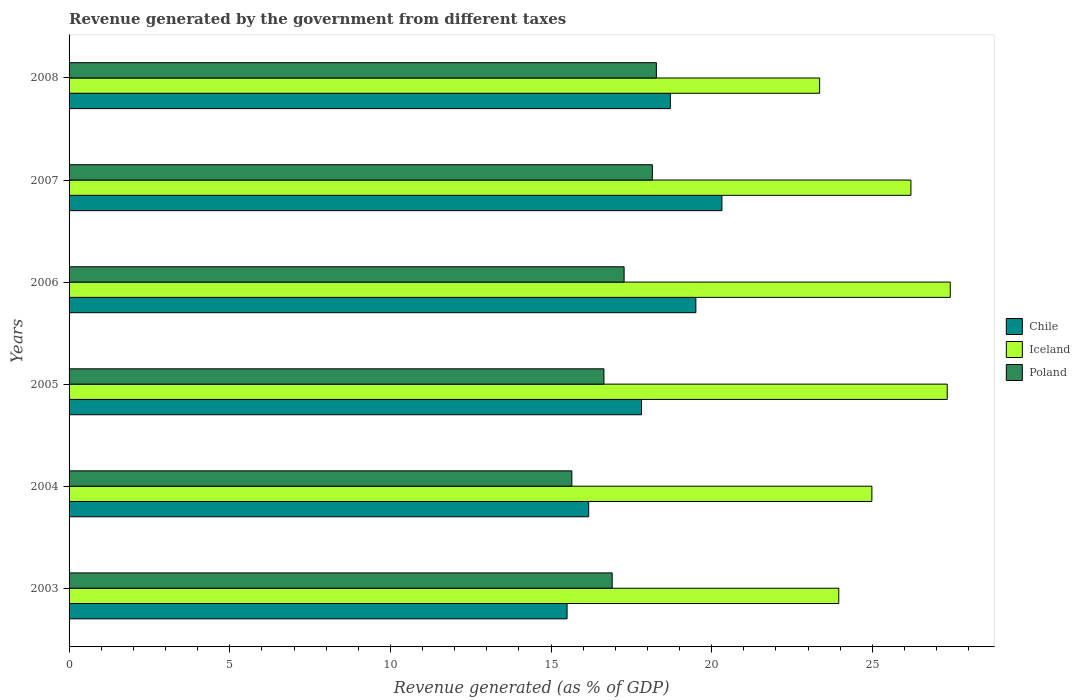How many different coloured bars are there?
Offer a terse response. 3. Are the number of bars on each tick of the Y-axis equal?
Offer a very short reply. Yes. What is the label of the 1st group of bars from the top?
Ensure brevity in your answer.  2008. In how many cases, is the number of bars for a given year not equal to the number of legend labels?
Your response must be concise. 0. What is the revenue generated by the government in Iceland in 2005?
Give a very brief answer. 27.33. Across all years, what is the maximum revenue generated by the government in Iceland?
Your answer should be very brief. 27.42. Across all years, what is the minimum revenue generated by the government in Iceland?
Give a very brief answer. 23.36. In which year was the revenue generated by the government in Iceland maximum?
Offer a terse response. 2006. What is the total revenue generated by the government in Iceland in the graph?
Provide a short and direct response. 153.25. What is the difference between the revenue generated by the government in Chile in 2007 and that in 2008?
Keep it short and to the point. 1.61. What is the difference between the revenue generated by the government in Iceland in 2004 and the revenue generated by the government in Poland in 2005?
Your answer should be very brief. 8.34. What is the average revenue generated by the government in Chile per year?
Your answer should be compact. 18. In the year 2008, what is the difference between the revenue generated by the government in Poland and revenue generated by the government in Chile?
Your answer should be compact. -0.44. What is the ratio of the revenue generated by the government in Iceland in 2003 to that in 2006?
Provide a succinct answer. 0.87. Is the revenue generated by the government in Poland in 2005 less than that in 2007?
Keep it short and to the point. Yes. Is the difference between the revenue generated by the government in Poland in 2005 and 2007 greater than the difference between the revenue generated by the government in Chile in 2005 and 2007?
Offer a very short reply. Yes. What is the difference between the highest and the second highest revenue generated by the government in Poland?
Your answer should be very brief. 0.13. What is the difference between the highest and the lowest revenue generated by the government in Poland?
Ensure brevity in your answer.  2.63. In how many years, is the revenue generated by the government in Chile greater than the average revenue generated by the government in Chile taken over all years?
Offer a terse response. 3. What does the 3rd bar from the top in 2005 represents?
Your answer should be compact. Chile. What does the 3rd bar from the bottom in 2004 represents?
Your response must be concise. Poland. How many bars are there?
Give a very brief answer. 18. Does the graph contain any zero values?
Provide a short and direct response. No. How many legend labels are there?
Ensure brevity in your answer.  3. How are the legend labels stacked?
Keep it short and to the point. Vertical. What is the title of the graph?
Offer a very short reply. Revenue generated by the government from different taxes. Does "Haiti" appear as one of the legend labels in the graph?
Make the answer very short. No. What is the label or title of the X-axis?
Provide a succinct answer. Revenue generated (as % of GDP). What is the Revenue generated (as % of GDP) of Chile in 2003?
Provide a short and direct response. 15.5. What is the Revenue generated (as % of GDP) in Iceland in 2003?
Offer a terse response. 23.95. What is the Revenue generated (as % of GDP) of Poland in 2003?
Provide a short and direct response. 16.9. What is the Revenue generated (as % of GDP) in Chile in 2004?
Provide a short and direct response. 16.17. What is the Revenue generated (as % of GDP) of Iceland in 2004?
Ensure brevity in your answer.  24.98. What is the Revenue generated (as % of GDP) in Poland in 2004?
Keep it short and to the point. 15.65. What is the Revenue generated (as % of GDP) in Chile in 2005?
Keep it short and to the point. 17.82. What is the Revenue generated (as % of GDP) of Iceland in 2005?
Ensure brevity in your answer.  27.33. What is the Revenue generated (as % of GDP) in Poland in 2005?
Give a very brief answer. 16.65. What is the Revenue generated (as % of GDP) in Chile in 2006?
Ensure brevity in your answer.  19.51. What is the Revenue generated (as % of GDP) in Iceland in 2006?
Your answer should be very brief. 27.42. What is the Revenue generated (as % of GDP) of Poland in 2006?
Offer a terse response. 17.27. What is the Revenue generated (as % of GDP) in Chile in 2007?
Provide a short and direct response. 20.32. What is the Revenue generated (as % of GDP) in Iceland in 2007?
Provide a short and direct response. 26.2. What is the Revenue generated (as % of GDP) in Poland in 2007?
Make the answer very short. 18.15. What is the Revenue generated (as % of GDP) in Chile in 2008?
Provide a succinct answer. 18.71. What is the Revenue generated (as % of GDP) of Iceland in 2008?
Offer a very short reply. 23.36. What is the Revenue generated (as % of GDP) of Poland in 2008?
Make the answer very short. 18.28. Across all years, what is the maximum Revenue generated (as % of GDP) in Chile?
Your answer should be compact. 20.32. Across all years, what is the maximum Revenue generated (as % of GDP) of Iceland?
Keep it short and to the point. 27.42. Across all years, what is the maximum Revenue generated (as % of GDP) of Poland?
Offer a terse response. 18.28. Across all years, what is the minimum Revenue generated (as % of GDP) in Chile?
Your response must be concise. 15.5. Across all years, what is the minimum Revenue generated (as % of GDP) in Iceland?
Ensure brevity in your answer.  23.36. Across all years, what is the minimum Revenue generated (as % of GDP) in Poland?
Provide a short and direct response. 15.65. What is the total Revenue generated (as % of GDP) in Chile in the graph?
Keep it short and to the point. 108.02. What is the total Revenue generated (as % of GDP) in Iceland in the graph?
Your answer should be compact. 153.25. What is the total Revenue generated (as % of GDP) in Poland in the graph?
Provide a short and direct response. 102.9. What is the difference between the Revenue generated (as % of GDP) in Chile in 2003 and that in 2004?
Your response must be concise. -0.67. What is the difference between the Revenue generated (as % of GDP) of Iceland in 2003 and that in 2004?
Your response must be concise. -1.03. What is the difference between the Revenue generated (as % of GDP) of Poland in 2003 and that in 2004?
Ensure brevity in your answer.  1.26. What is the difference between the Revenue generated (as % of GDP) of Chile in 2003 and that in 2005?
Your response must be concise. -2.32. What is the difference between the Revenue generated (as % of GDP) of Iceland in 2003 and that in 2005?
Ensure brevity in your answer.  -3.38. What is the difference between the Revenue generated (as % of GDP) of Poland in 2003 and that in 2005?
Make the answer very short. 0.26. What is the difference between the Revenue generated (as % of GDP) in Chile in 2003 and that in 2006?
Your response must be concise. -4.01. What is the difference between the Revenue generated (as % of GDP) of Iceland in 2003 and that in 2006?
Your response must be concise. -3.47. What is the difference between the Revenue generated (as % of GDP) of Poland in 2003 and that in 2006?
Make the answer very short. -0.37. What is the difference between the Revenue generated (as % of GDP) in Chile in 2003 and that in 2007?
Provide a short and direct response. -4.82. What is the difference between the Revenue generated (as % of GDP) in Iceland in 2003 and that in 2007?
Give a very brief answer. -2.25. What is the difference between the Revenue generated (as % of GDP) in Poland in 2003 and that in 2007?
Ensure brevity in your answer.  -1.25. What is the difference between the Revenue generated (as % of GDP) of Chile in 2003 and that in 2008?
Make the answer very short. -3.21. What is the difference between the Revenue generated (as % of GDP) in Iceland in 2003 and that in 2008?
Your response must be concise. 0.6. What is the difference between the Revenue generated (as % of GDP) in Poland in 2003 and that in 2008?
Offer a very short reply. -1.38. What is the difference between the Revenue generated (as % of GDP) of Chile in 2004 and that in 2005?
Give a very brief answer. -1.65. What is the difference between the Revenue generated (as % of GDP) in Iceland in 2004 and that in 2005?
Your answer should be very brief. -2.35. What is the difference between the Revenue generated (as % of GDP) of Poland in 2004 and that in 2005?
Provide a succinct answer. -1. What is the difference between the Revenue generated (as % of GDP) of Chile in 2004 and that in 2006?
Give a very brief answer. -3.34. What is the difference between the Revenue generated (as % of GDP) of Iceland in 2004 and that in 2006?
Give a very brief answer. -2.44. What is the difference between the Revenue generated (as % of GDP) in Poland in 2004 and that in 2006?
Give a very brief answer. -1.63. What is the difference between the Revenue generated (as % of GDP) in Chile in 2004 and that in 2007?
Give a very brief answer. -4.15. What is the difference between the Revenue generated (as % of GDP) of Iceland in 2004 and that in 2007?
Your answer should be very brief. -1.22. What is the difference between the Revenue generated (as % of GDP) of Poland in 2004 and that in 2007?
Your response must be concise. -2.51. What is the difference between the Revenue generated (as % of GDP) of Chile in 2004 and that in 2008?
Your answer should be compact. -2.54. What is the difference between the Revenue generated (as % of GDP) of Iceland in 2004 and that in 2008?
Provide a succinct answer. 1.63. What is the difference between the Revenue generated (as % of GDP) of Poland in 2004 and that in 2008?
Provide a short and direct response. -2.63. What is the difference between the Revenue generated (as % of GDP) in Chile in 2005 and that in 2006?
Offer a terse response. -1.69. What is the difference between the Revenue generated (as % of GDP) in Iceland in 2005 and that in 2006?
Your answer should be very brief. -0.09. What is the difference between the Revenue generated (as % of GDP) of Poland in 2005 and that in 2006?
Provide a short and direct response. -0.63. What is the difference between the Revenue generated (as % of GDP) of Chile in 2005 and that in 2007?
Offer a terse response. -2.5. What is the difference between the Revenue generated (as % of GDP) in Iceland in 2005 and that in 2007?
Give a very brief answer. 1.13. What is the difference between the Revenue generated (as % of GDP) in Poland in 2005 and that in 2007?
Keep it short and to the point. -1.51. What is the difference between the Revenue generated (as % of GDP) in Chile in 2005 and that in 2008?
Provide a succinct answer. -0.9. What is the difference between the Revenue generated (as % of GDP) of Iceland in 2005 and that in 2008?
Provide a succinct answer. 3.97. What is the difference between the Revenue generated (as % of GDP) of Poland in 2005 and that in 2008?
Your answer should be compact. -1.63. What is the difference between the Revenue generated (as % of GDP) of Chile in 2006 and that in 2007?
Your answer should be very brief. -0.81. What is the difference between the Revenue generated (as % of GDP) of Iceland in 2006 and that in 2007?
Keep it short and to the point. 1.22. What is the difference between the Revenue generated (as % of GDP) in Poland in 2006 and that in 2007?
Make the answer very short. -0.88. What is the difference between the Revenue generated (as % of GDP) of Chile in 2006 and that in 2008?
Offer a very short reply. 0.79. What is the difference between the Revenue generated (as % of GDP) in Iceland in 2006 and that in 2008?
Make the answer very short. 4.07. What is the difference between the Revenue generated (as % of GDP) in Poland in 2006 and that in 2008?
Offer a very short reply. -1. What is the difference between the Revenue generated (as % of GDP) in Chile in 2007 and that in 2008?
Keep it short and to the point. 1.61. What is the difference between the Revenue generated (as % of GDP) in Iceland in 2007 and that in 2008?
Ensure brevity in your answer.  2.84. What is the difference between the Revenue generated (as % of GDP) of Poland in 2007 and that in 2008?
Your answer should be very brief. -0.13. What is the difference between the Revenue generated (as % of GDP) in Chile in 2003 and the Revenue generated (as % of GDP) in Iceland in 2004?
Offer a terse response. -9.49. What is the difference between the Revenue generated (as % of GDP) of Chile in 2003 and the Revenue generated (as % of GDP) of Poland in 2004?
Provide a succinct answer. -0.15. What is the difference between the Revenue generated (as % of GDP) in Iceland in 2003 and the Revenue generated (as % of GDP) in Poland in 2004?
Your answer should be compact. 8.31. What is the difference between the Revenue generated (as % of GDP) in Chile in 2003 and the Revenue generated (as % of GDP) in Iceland in 2005?
Ensure brevity in your answer.  -11.83. What is the difference between the Revenue generated (as % of GDP) of Chile in 2003 and the Revenue generated (as % of GDP) of Poland in 2005?
Your response must be concise. -1.15. What is the difference between the Revenue generated (as % of GDP) in Iceland in 2003 and the Revenue generated (as % of GDP) in Poland in 2005?
Offer a terse response. 7.31. What is the difference between the Revenue generated (as % of GDP) of Chile in 2003 and the Revenue generated (as % of GDP) of Iceland in 2006?
Your response must be concise. -11.93. What is the difference between the Revenue generated (as % of GDP) in Chile in 2003 and the Revenue generated (as % of GDP) in Poland in 2006?
Give a very brief answer. -1.77. What is the difference between the Revenue generated (as % of GDP) in Iceland in 2003 and the Revenue generated (as % of GDP) in Poland in 2006?
Give a very brief answer. 6.68. What is the difference between the Revenue generated (as % of GDP) in Chile in 2003 and the Revenue generated (as % of GDP) in Iceland in 2007?
Ensure brevity in your answer.  -10.7. What is the difference between the Revenue generated (as % of GDP) in Chile in 2003 and the Revenue generated (as % of GDP) in Poland in 2007?
Your answer should be compact. -2.65. What is the difference between the Revenue generated (as % of GDP) of Iceland in 2003 and the Revenue generated (as % of GDP) of Poland in 2007?
Your response must be concise. 5.8. What is the difference between the Revenue generated (as % of GDP) of Chile in 2003 and the Revenue generated (as % of GDP) of Iceland in 2008?
Offer a very short reply. -7.86. What is the difference between the Revenue generated (as % of GDP) in Chile in 2003 and the Revenue generated (as % of GDP) in Poland in 2008?
Provide a succinct answer. -2.78. What is the difference between the Revenue generated (as % of GDP) in Iceland in 2003 and the Revenue generated (as % of GDP) in Poland in 2008?
Your answer should be very brief. 5.68. What is the difference between the Revenue generated (as % of GDP) in Chile in 2004 and the Revenue generated (as % of GDP) in Iceland in 2005?
Your answer should be compact. -11.16. What is the difference between the Revenue generated (as % of GDP) of Chile in 2004 and the Revenue generated (as % of GDP) of Poland in 2005?
Offer a terse response. -0.48. What is the difference between the Revenue generated (as % of GDP) of Iceland in 2004 and the Revenue generated (as % of GDP) of Poland in 2005?
Your answer should be compact. 8.34. What is the difference between the Revenue generated (as % of GDP) in Chile in 2004 and the Revenue generated (as % of GDP) in Iceland in 2006?
Offer a very short reply. -11.25. What is the difference between the Revenue generated (as % of GDP) of Chile in 2004 and the Revenue generated (as % of GDP) of Poland in 2006?
Make the answer very short. -1.1. What is the difference between the Revenue generated (as % of GDP) in Iceland in 2004 and the Revenue generated (as % of GDP) in Poland in 2006?
Your answer should be very brief. 7.71. What is the difference between the Revenue generated (as % of GDP) in Chile in 2004 and the Revenue generated (as % of GDP) in Iceland in 2007?
Give a very brief answer. -10.03. What is the difference between the Revenue generated (as % of GDP) in Chile in 2004 and the Revenue generated (as % of GDP) in Poland in 2007?
Provide a succinct answer. -1.98. What is the difference between the Revenue generated (as % of GDP) in Iceland in 2004 and the Revenue generated (as % of GDP) in Poland in 2007?
Keep it short and to the point. 6.83. What is the difference between the Revenue generated (as % of GDP) of Chile in 2004 and the Revenue generated (as % of GDP) of Iceland in 2008?
Your answer should be compact. -7.19. What is the difference between the Revenue generated (as % of GDP) in Chile in 2004 and the Revenue generated (as % of GDP) in Poland in 2008?
Ensure brevity in your answer.  -2.11. What is the difference between the Revenue generated (as % of GDP) in Iceland in 2004 and the Revenue generated (as % of GDP) in Poland in 2008?
Provide a short and direct response. 6.71. What is the difference between the Revenue generated (as % of GDP) in Chile in 2005 and the Revenue generated (as % of GDP) in Iceland in 2006?
Offer a terse response. -9.61. What is the difference between the Revenue generated (as % of GDP) in Chile in 2005 and the Revenue generated (as % of GDP) in Poland in 2006?
Make the answer very short. 0.54. What is the difference between the Revenue generated (as % of GDP) of Iceland in 2005 and the Revenue generated (as % of GDP) of Poland in 2006?
Ensure brevity in your answer.  10.06. What is the difference between the Revenue generated (as % of GDP) in Chile in 2005 and the Revenue generated (as % of GDP) in Iceland in 2007?
Ensure brevity in your answer.  -8.38. What is the difference between the Revenue generated (as % of GDP) of Chile in 2005 and the Revenue generated (as % of GDP) of Poland in 2007?
Give a very brief answer. -0.34. What is the difference between the Revenue generated (as % of GDP) in Iceland in 2005 and the Revenue generated (as % of GDP) in Poland in 2007?
Your answer should be compact. 9.18. What is the difference between the Revenue generated (as % of GDP) of Chile in 2005 and the Revenue generated (as % of GDP) of Iceland in 2008?
Your response must be concise. -5.54. What is the difference between the Revenue generated (as % of GDP) in Chile in 2005 and the Revenue generated (as % of GDP) in Poland in 2008?
Provide a short and direct response. -0.46. What is the difference between the Revenue generated (as % of GDP) of Iceland in 2005 and the Revenue generated (as % of GDP) of Poland in 2008?
Provide a short and direct response. 9.05. What is the difference between the Revenue generated (as % of GDP) of Chile in 2006 and the Revenue generated (as % of GDP) of Iceland in 2007?
Provide a succinct answer. -6.69. What is the difference between the Revenue generated (as % of GDP) of Chile in 2006 and the Revenue generated (as % of GDP) of Poland in 2007?
Your response must be concise. 1.35. What is the difference between the Revenue generated (as % of GDP) in Iceland in 2006 and the Revenue generated (as % of GDP) in Poland in 2007?
Offer a terse response. 9.27. What is the difference between the Revenue generated (as % of GDP) of Chile in 2006 and the Revenue generated (as % of GDP) of Iceland in 2008?
Provide a succinct answer. -3.85. What is the difference between the Revenue generated (as % of GDP) of Chile in 2006 and the Revenue generated (as % of GDP) of Poland in 2008?
Provide a short and direct response. 1.23. What is the difference between the Revenue generated (as % of GDP) of Iceland in 2006 and the Revenue generated (as % of GDP) of Poland in 2008?
Your answer should be very brief. 9.15. What is the difference between the Revenue generated (as % of GDP) in Chile in 2007 and the Revenue generated (as % of GDP) in Iceland in 2008?
Offer a very short reply. -3.04. What is the difference between the Revenue generated (as % of GDP) in Chile in 2007 and the Revenue generated (as % of GDP) in Poland in 2008?
Keep it short and to the point. 2.04. What is the difference between the Revenue generated (as % of GDP) of Iceland in 2007 and the Revenue generated (as % of GDP) of Poland in 2008?
Ensure brevity in your answer.  7.92. What is the average Revenue generated (as % of GDP) in Chile per year?
Keep it short and to the point. 18. What is the average Revenue generated (as % of GDP) in Iceland per year?
Offer a terse response. 25.54. What is the average Revenue generated (as % of GDP) in Poland per year?
Offer a terse response. 17.15. In the year 2003, what is the difference between the Revenue generated (as % of GDP) of Chile and Revenue generated (as % of GDP) of Iceland?
Keep it short and to the point. -8.46. In the year 2003, what is the difference between the Revenue generated (as % of GDP) of Chile and Revenue generated (as % of GDP) of Poland?
Your response must be concise. -1.4. In the year 2003, what is the difference between the Revenue generated (as % of GDP) in Iceland and Revenue generated (as % of GDP) in Poland?
Give a very brief answer. 7.05. In the year 2004, what is the difference between the Revenue generated (as % of GDP) in Chile and Revenue generated (as % of GDP) in Iceland?
Keep it short and to the point. -8.81. In the year 2004, what is the difference between the Revenue generated (as % of GDP) in Chile and Revenue generated (as % of GDP) in Poland?
Your response must be concise. 0.52. In the year 2004, what is the difference between the Revenue generated (as % of GDP) of Iceland and Revenue generated (as % of GDP) of Poland?
Your response must be concise. 9.34. In the year 2005, what is the difference between the Revenue generated (as % of GDP) in Chile and Revenue generated (as % of GDP) in Iceland?
Keep it short and to the point. -9.51. In the year 2005, what is the difference between the Revenue generated (as % of GDP) of Chile and Revenue generated (as % of GDP) of Poland?
Make the answer very short. 1.17. In the year 2005, what is the difference between the Revenue generated (as % of GDP) in Iceland and Revenue generated (as % of GDP) in Poland?
Your response must be concise. 10.68. In the year 2006, what is the difference between the Revenue generated (as % of GDP) in Chile and Revenue generated (as % of GDP) in Iceland?
Your answer should be compact. -7.92. In the year 2006, what is the difference between the Revenue generated (as % of GDP) of Chile and Revenue generated (as % of GDP) of Poland?
Keep it short and to the point. 2.23. In the year 2006, what is the difference between the Revenue generated (as % of GDP) in Iceland and Revenue generated (as % of GDP) in Poland?
Provide a short and direct response. 10.15. In the year 2007, what is the difference between the Revenue generated (as % of GDP) in Chile and Revenue generated (as % of GDP) in Iceland?
Provide a succinct answer. -5.88. In the year 2007, what is the difference between the Revenue generated (as % of GDP) of Chile and Revenue generated (as % of GDP) of Poland?
Offer a very short reply. 2.17. In the year 2007, what is the difference between the Revenue generated (as % of GDP) in Iceland and Revenue generated (as % of GDP) in Poland?
Ensure brevity in your answer.  8.05. In the year 2008, what is the difference between the Revenue generated (as % of GDP) in Chile and Revenue generated (as % of GDP) in Iceland?
Your response must be concise. -4.65. In the year 2008, what is the difference between the Revenue generated (as % of GDP) of Chile and Revenue generated (as % of GDP) of Poland?
Your answer should be very brief. 0.44. In the year 2008, what is the difference between the Revenue generated (as % of GDP) of Iceland and Revenue generated (as % of GDP) of Poland?
Make the answer very short. 5.08. What is the ratio of the Revenue generated (as % of GDP) in Chile in 2003 to that in 2004?
Provide a succinct answer. 0.96. What is the ratio of the Revenue generated (as % of GDP) in Iceland in 2003 to that in 2004?
Provide a succinct answer. 0.96. What is the ratio of the Revenue generated (as % of GDP) of Poland in 2003 to that in 2004?
Your answer should be compact. 1.08. What is the ratio of the Revenue generated (as % of GDP) of Chile in 2003 to that in 2005?
Provide a succinct answer. 0.87. What is the ratio of the Revenue generated (as % of GDP) in Iceland in 2003 to that in 2005?
Keep it short and to the point. 0.88. What is the ratio of the Revenue generated (as % of GDP) in Poland in 2003 to that in 2005?
Your answer should be compact. 1.02. What is the ratio of the Revenue generated (as % of GDP) in Chile in 2003 to that in 2006?
Make the answer very short. 0.79. What is the ratio of the Revenue generated (as % of GDP) of Iceland in 2003 to that in 2006?
Offer a terse response. 0.87. What is the ratio of the Revenue generated (as % of GDP) in Poland in 2003 to that in 2006?
Give a very brief answer. 0.98. What is the ratio of the Revenue generated (as % of GDP) in Chile in 2003 to that in 2007?
Your answer should be very brief. 0.76. What is the ratio of the Revenue generated (as % of GDP) of Iceland in 2003 to that in 2007?
Offer a very short reply. 0.91. What is the ratio of the Revenue generated (as % of GDP) in Poland in 2003 to that in 2007?
Your answer should be very brief. 0.93. What is the ratio of the Revenue generated (as % of GDP) in Chile in 2003 to that in 2008?
Your answer should be very brief. 0.83. What is the ratio of the Revenue generated (as % of GDP) of Iceland in 2003 to that in 2008?
Ensure brevity in your answer.  1.03. What is the ratio of the Revenue generated (as % of GDP) of Poland in 2003 to that in 2008?
Offer a terse response. 0.92. What is the ratio of the Revenue generated (as % of GDP) in Chile in 2004 to that in 2005?
Your answer should be compact. 0.91. What is the ratio of the Revenue generated (as % of GDP) in Iceland in 2004 to that in 2005?
Provide a short and direct response. 0.91. What is the ratio of the Revenue generated (as % of GDP) of Poland in 2004 to that in 2005?
Your answer should be compact. 0.94. What is the ratio of the Revenue generated (as % of GDP) of Chile in 2004 to that in 2006?
Ensure brevity in your answer.  0.83. What is the ratio of the Revenue generated (as % of GDP) in Iceland in 2004 to that in 2006?
Provide a short and direct response. 0.91. What is the ratio of the Revenue generated (as % of GDP) in Poland in 2004 to that in 2006?
Offer a terse response. 0.91. What is the ratio of the Revenue generated (as % of GDP) in Chile in 2004 to that in 2007?
Ensure brevity in your answer.  0.8. What is the ratio of the Revenue generated (as % of GDP) of Iceland in 2004 to that in 2007?
Your answer should be compact. 0.95. What is the ratio of the Revenue generated (as % of GDP) of Poland in 2004 to that in 2007?
Your answer should be compact. 0.86. What is the ratio of the Revenue generated (as % of GDP) in Chile in 2004 to that in 2008?
Make the answer very short. 0.86. What is the ratio of the Revenue generated (as % of GDP) in Iceland in 2004 to that in 2008?
Your answer should be very brief. 1.07. What is the ratio of the Revenue generated (as % of GDP) in Poland in 2004 to that in 2008?
Your answer should be very brief. 0.86. What is the ratio of the Revenue generated (as % of GDP) of Chile in 2005 to that in 2006?
Your response must be concise. 0.91. What is the ratio of the Revenue generated (as % of GDP) in Iceland in 2005 to that in 2006?
Make the answer very short. 1. What is the ratio of the Revenue generated (as % of GDP) of Poland in 2005 to that in 2006?
Your response must be concise. 0.96. What is the ratio of the Revenue generated (as % of GDP) of Chile in 2005 to that in 2007?
Keep it short and to the point. 0.88. What is the ratio of the Revenue generated (as % of GDP) in Iceland in 2005 to that in 2007?
Your response must be concise. 1.04. What is the ratio of the Revenue generated (as % of GDP) of Poland in 2005 to that in 2007?
Give a very brief answer. 0.92. What is the ratio of the Revenue generated (as % of GDP) in Chile in 2005 to that in 2008?
Provide a succinct answer. 0.95. What is the ratio of the Revenue generated (as % of GDP) of Iceland in 2005 to that in 2008?
Your answer should be compact. 1.17. What is the ratio of the Revenue generated (as % of GDP) in Poland in 2005 to that in 2008?
Keep it short and to the point. 0.91. What is the ratio of the Revenue generated (as % of GDP) in Chile in 2006 to that in 2007?
Give a very brief answer. 0.96. What is the ratio of the Revenue generated (as % of GDP) in Iceland in 2006 to that in 2007?
Offer a terse response. 1.05. What is the ratio of the Revenue generated (as % of GDP) in Poland in 2006 to that in 2007?
Provide a succinct answer. 0.95. What is the ratio of the Revenue generated (as % of GDP) in Chile in 2006 to that in 2008?
Offer a very short reply. 1.04. What is the ratio of the Revenue generated (as % of GDP) in Iceland in 2006 to that in 2008?
Give a very brief answer. 1.17. What is the ratio of the Revenue generated (as % of GDP) in Poland in 2006 to that in 2008?
Provide a succinct answer. 0.95. What is the ratio of the Revenue generated (as % of GDP) in Chile in 2007 to that in 2008?
Provide a succinct answer. 1.09. What is the ratio of the Revenue generated (as % of GDP) of Iceland in 2007 to that in 2008?
Provide a short and direct response. 1.12. What is the difference between the highest and the second highest Revenue generated (as % of GDP) in Chile?
Your answer should be compact. 0.81. What is the difference between the highest and the second highest Revenue generated (as % of GDP) in Iceland?
Ensure brevity in your answer.  0.09. What is the difference between the highest and the second highest Revenue generated (as % of GDP) of Poland?
Keep it short and to the point. 0.13. What is the difference between the highest and the lowest Revenue generated (as % of GDP) of Chile?
Your answer should be very brief. 4.82. What is the difference between the highest and the lowest Revenue generated (as % of GDP) of Iceland?
Your response must be concise. 4.07. What is the difference between the highest and the lowest Revenue generated (as % of GDP) of Poland?
Your answer should be compact. 2.63. 